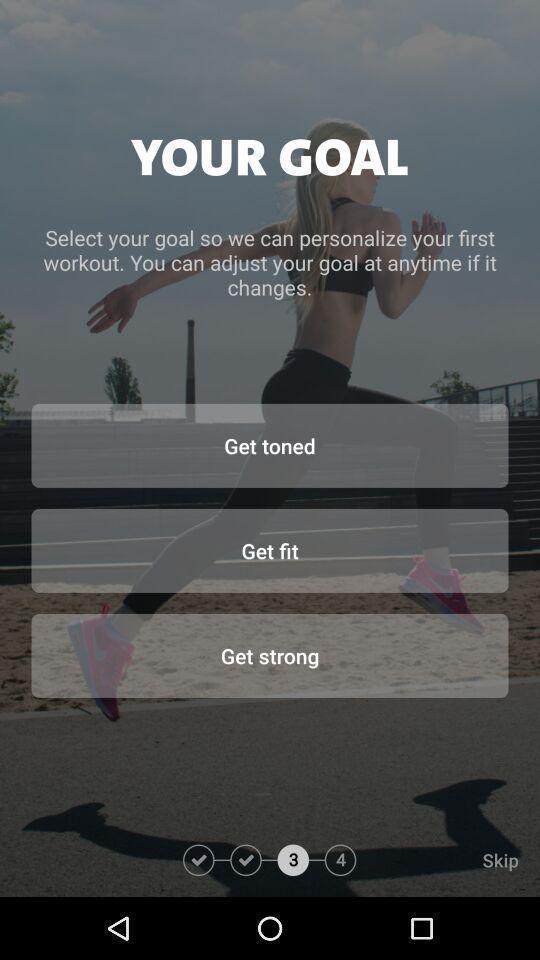Describe the visual elements of this screenshot. Welcome page. 